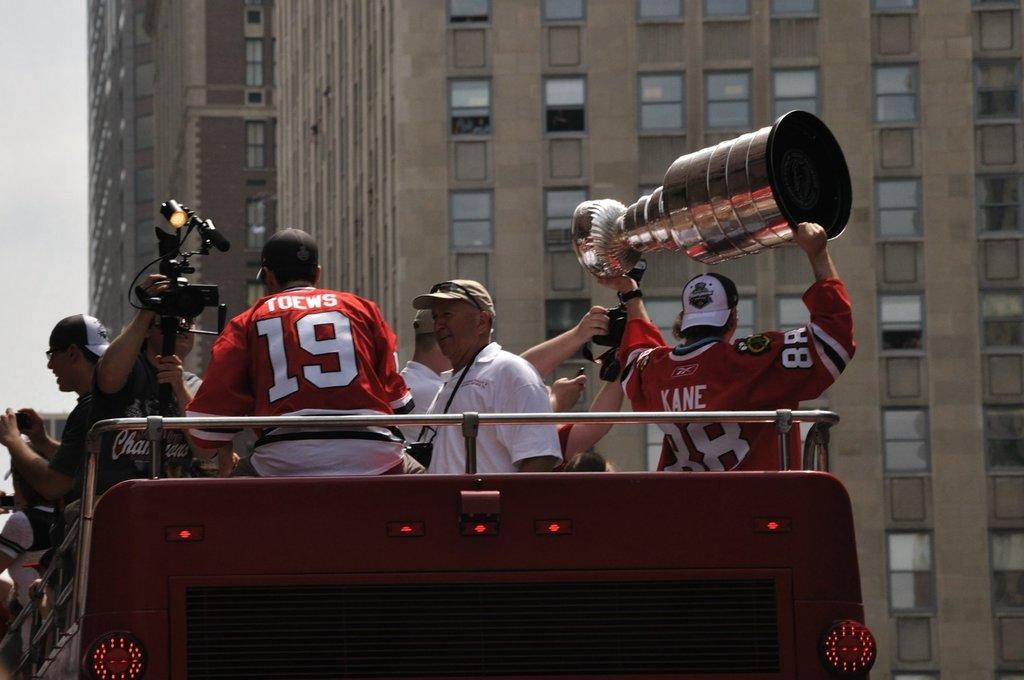What does it say on the back of the jerseys?
Make the answer very short. Toews and kane. 